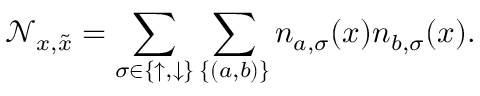<formula> <loc_0><loc_0><loc_500><loc_500>\mathcal { N } _ { x , \tilde { x } } = \sum _ { \sigma \in \{ \uparrow , \downarrow \} } \sum _ { \{ ( a , b ) \} } n _ { a , \sigma } ( x ) n _ { b , \sigma } ( x ) .</formula> 